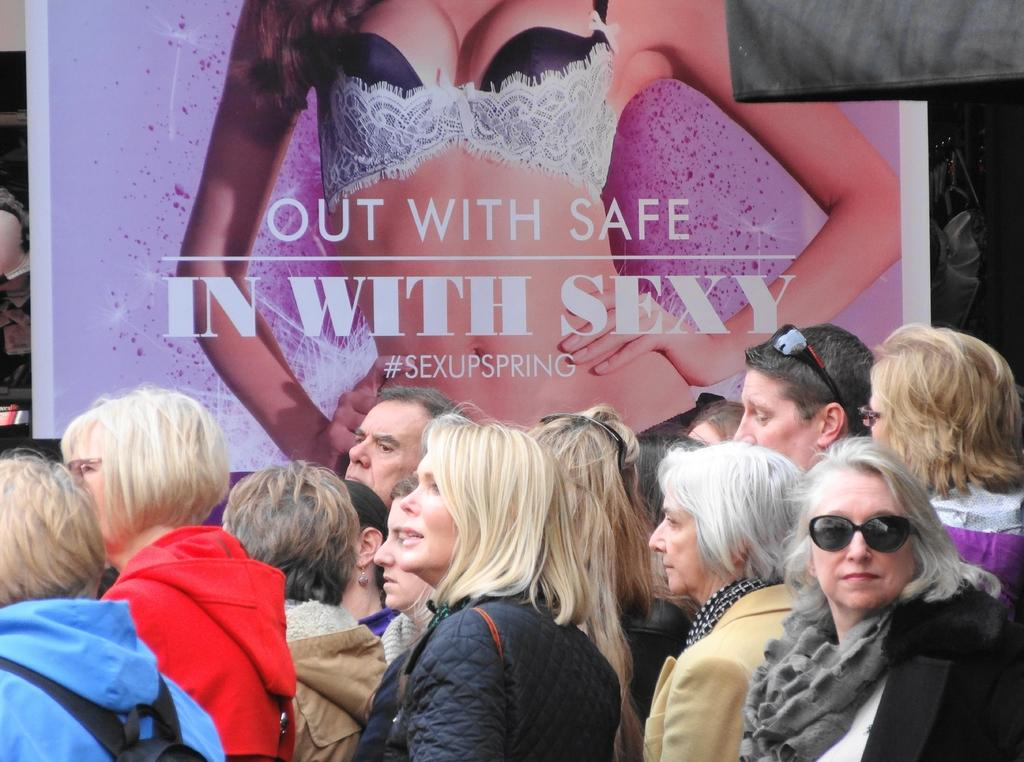Who or what can be seen in the image? There are people in the image. What else is present in the image besides the people? There is a banner in the image. Can you describe the banner in more detail? The banner has an image of a person and text on it. How many deer can be seen in the image? There are no deer present in the image. What riddle is written on the banner in the image? There is no riddle written on the banner in the image; it only has text and an image of a person. 